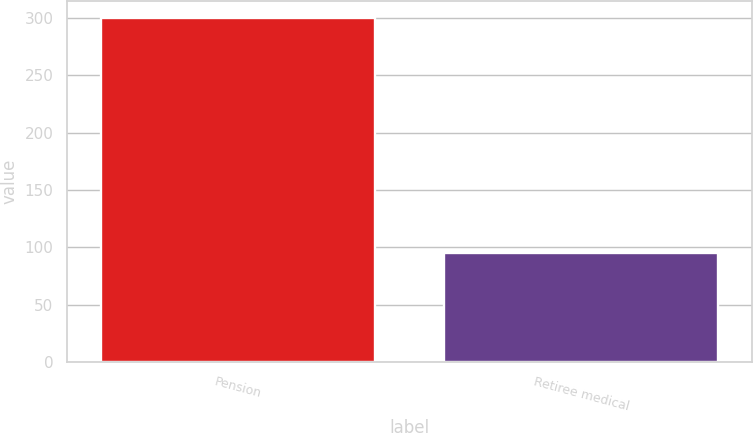<chart> <loc_0><loc_0><loc_500><loc_500><bar_chart><fcel>Pension<fcel>Retiree medical<nl><fcel>300<fcel>95<nl></chart> 